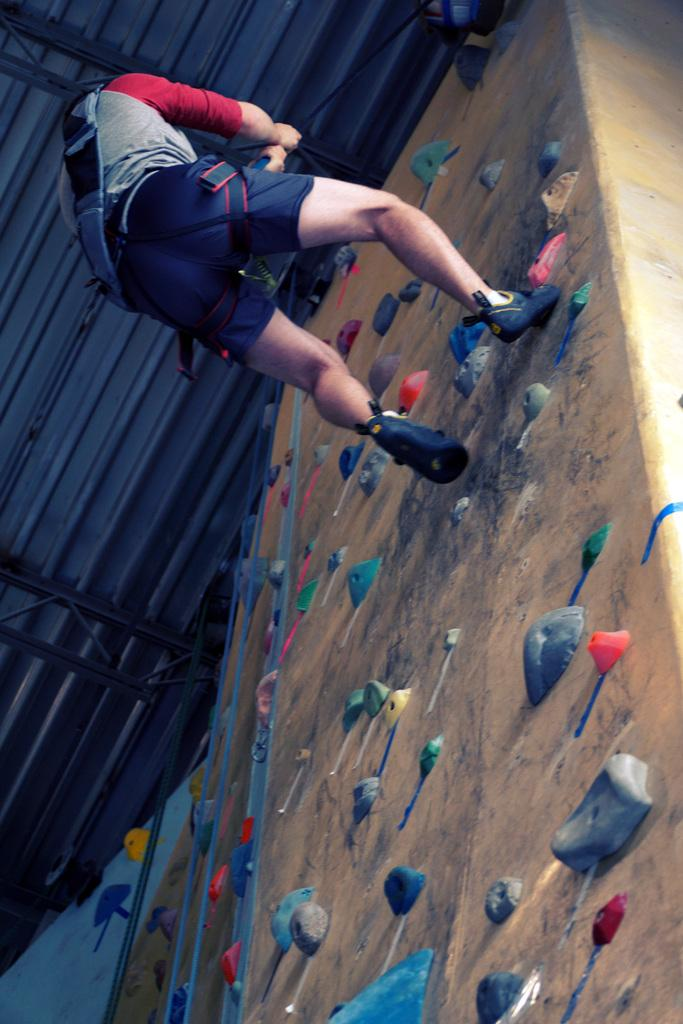What is attached to the wall in the image? There are colorful climbing holds on the wall. What is the man holding in the image? The man is holding a rope. What is the man doing in the image? The man is climbing the wall. Where is the kettle located in the image? There is no kettle present in the image. What time is displayed on the clock in the image? There is no clock present in the image. 